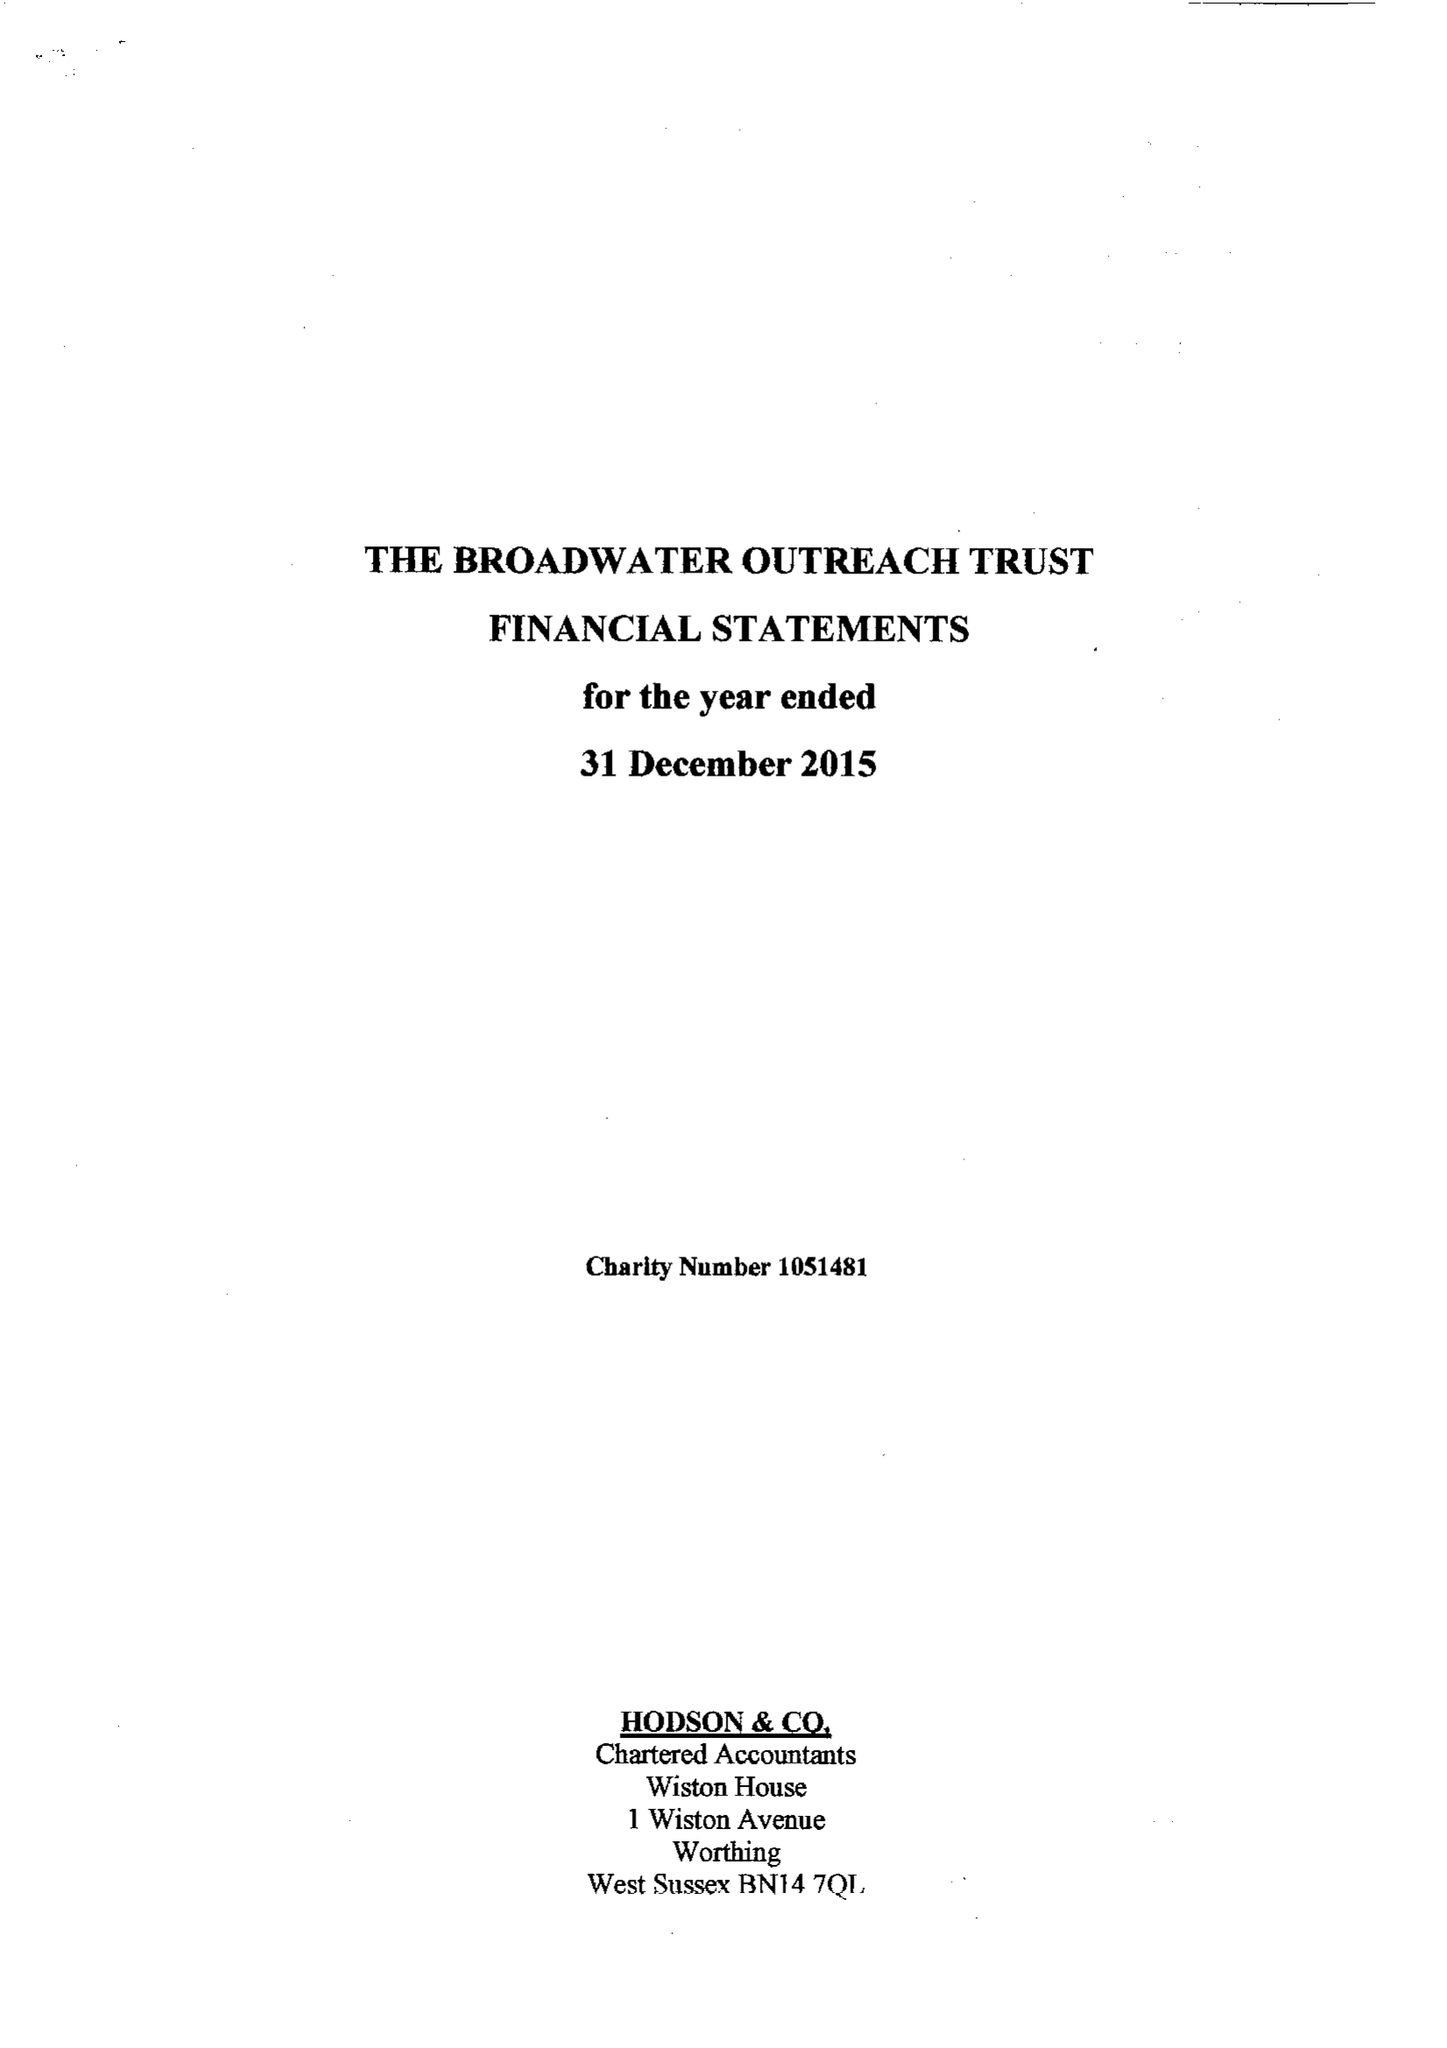What is the value for the charity_name?
Answer the question using a single word or phrase. The Broadwater Outreach Trust 